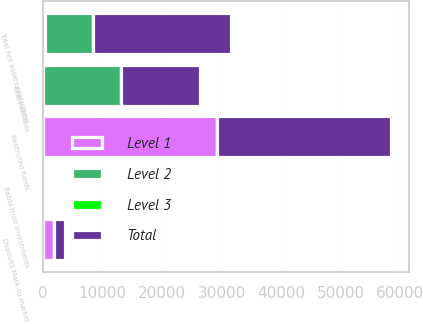Convert chart to OTSL. <chart><loc_0><loc_0><loc_500><loc_500><stacked_bar_chart><ecel><fcel>Restricted funds<fcel>Rabbi trust investments<fcel>Deposits Mark-to-market<fcel>Total liabilities<fcel>Total net assets (liabilities)<nl><fcel>Level 1<fcel>29259<fcel>0<fcel>1901<fcel>0<fcel>444<nl><fcel>Level 2<fcel>0<fcel>444<fcel>0<fcel>13204<fcel>7984<nl><fcel>Level 3<fcel>0<fcel>0<fcel>0<fcel>0<fcel>0<nl><fcel>Total<fcel>29259<fcel>444<fcel>1901<fcel>13204<fcel>23176<nl></chart> 